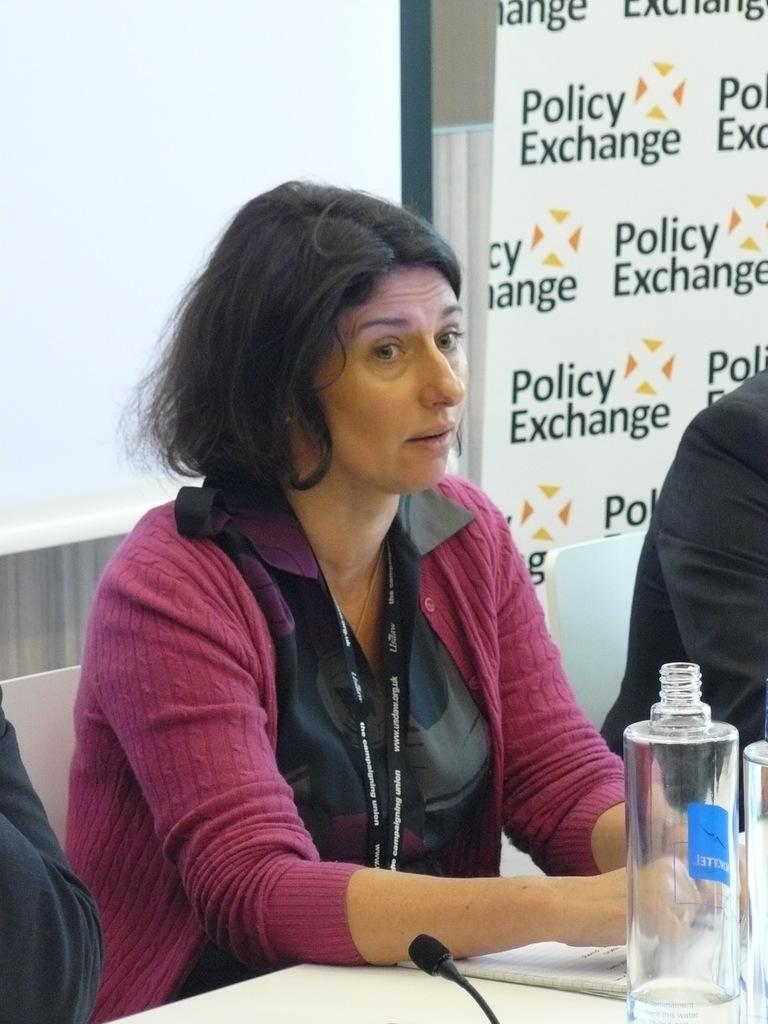<image>
Describe the image concisely. A woman sitting at a table, looking at someone, the wall behind says Polcy exchange 